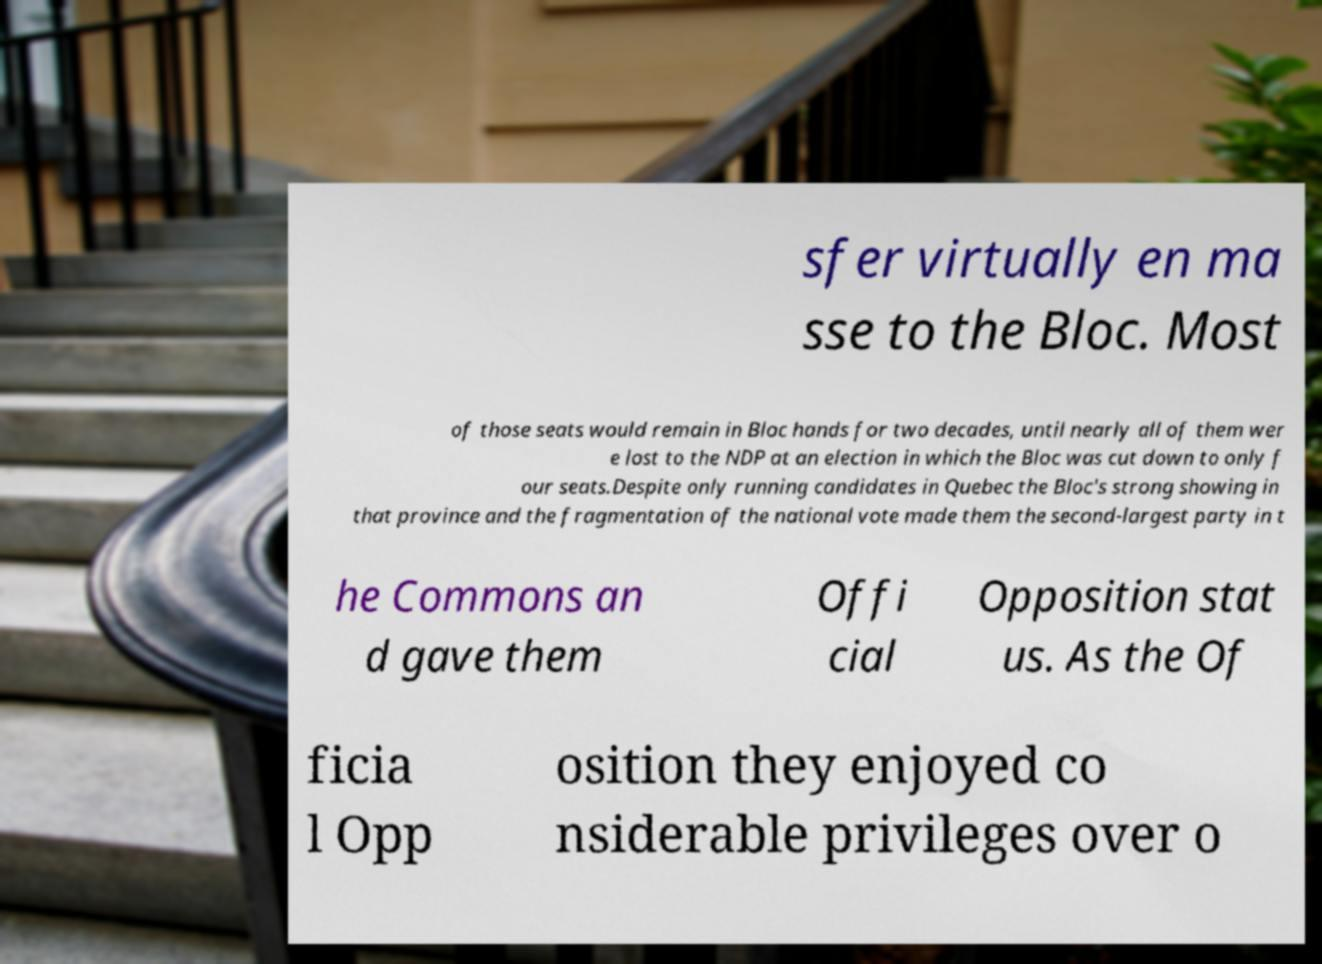There's text embedded in this image that I need extracted. Can you transcribe it verbatim? sfer virtually en ma sse to the Bloc. Most of those seats would remain in Bloc hands for two decades, until nearly all of them wer e lost to the NDP at an election in which the Bloc was cut down to only f our seats.Despite only running candidates in Quebec the Bloc's strong showing in that province and the fragmentation of the national vote made them the second-largest party in t he Commons an d gave them Offi cial Opposition stat us. As the Of ficia l Opp osition they enjoyed co nsiderable privileges over o 